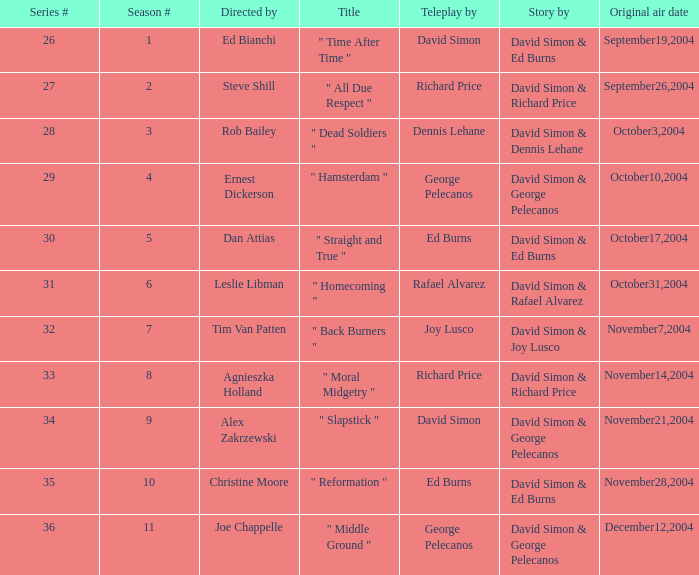What is the total number of values for "Teleplay by" category for series # 35? 1.0. 